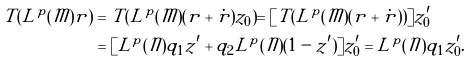<formula> <loc_0><loc_0><loc_500><loc_500>T ( L ^ { p } ( \mathcal { M } ) r ) & = T ( L ^ { p } ( \mathcal { M } ) ( r + \dot { r } ) z _ { 0 } ) = [ T ( L ^ { p } ( \mathcal { M } ) ( r + \dot { r } ) ) ] z _ { 0 } ^ { \prime } \\ & = [ L ^ { p } ( \mathcal { N } ) q _ { 1 } z ^ { \prime } + q _ { 2 } L ^ { p } ( \mathcal { N } ) ( 1 - z ^ { \prime } ) ] z _ { 0 } ^ { \prime } = L ^ { p } ( \mathcal { N } ) q _ { 1 } z _ { 0 } ^ { \prime } .</formula> 